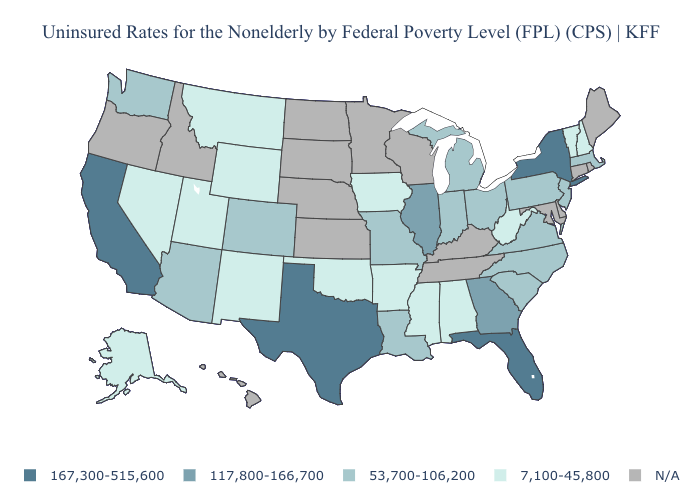What is the highest value in the Northeast ?
Write a very short answer. 167,300-515,600. Name the states that have a value in the range 167,300-515,600?
Write a very short answer. California, Florida, New York, Texas. How many symbols are there in the legend?
Concise answer only. 5. Is the legend a continuous bar?
Be succinct. No. How many symbols are there in the legend?
Give a very brief answer. 5. Name the states that have a value in the range N/A?
Be succinct. Connecticut, Delaware, Hawaii, Idaho, Kansas, Kentucky, Maine, Maryland, Minnesota, Nebraska, North Dakota, Oregon, Rhode Island, South Dakota, Tennessee, Wisconsin. What is the value of Alaska?
Answer briefly. 7,100-45,800. Name the states that have a value in the range 53,700-106,200?
Answer briefly. Arizona, Colorado, Indiana, Louisiana, Massachusetts, Michigan, Missouri, New Jersey, North Carolina, Ohio, Pennsylvania, South Carolina, Virginia, Washington. Name the states that have a value in the range 117,800-166,700?
Keep it brief. Georgia, Illinois. What is the highest value in states that border Iowa?
Answer briefly. 117,800-166,700. Name the states that have a value in the range N/A?
Concise answer only. Connecticut, Delaware, Hawaii, Idaho, Kansas, Kentucky, Maine, Maryland, Minnesota, Nebraska, North Dakota, Oregon, Rhode Island, South Dakota, Tennessee, Wisconsin. Name the states that have a value in the range 7,100-45,800?
Give a very brief answer. Alabama, Alaska, Arkansas, Iowa, Mississippi, Montana, Nevada, New Hampshire, New Mexico, Oklahoma, Utah, Vermont, West Virginia, Wyoming. What is the value of Virginia?
Short answer required. 53,700-106,200. What is the value of New Jersey?
Write a very short answer. 53,700-106,200. 